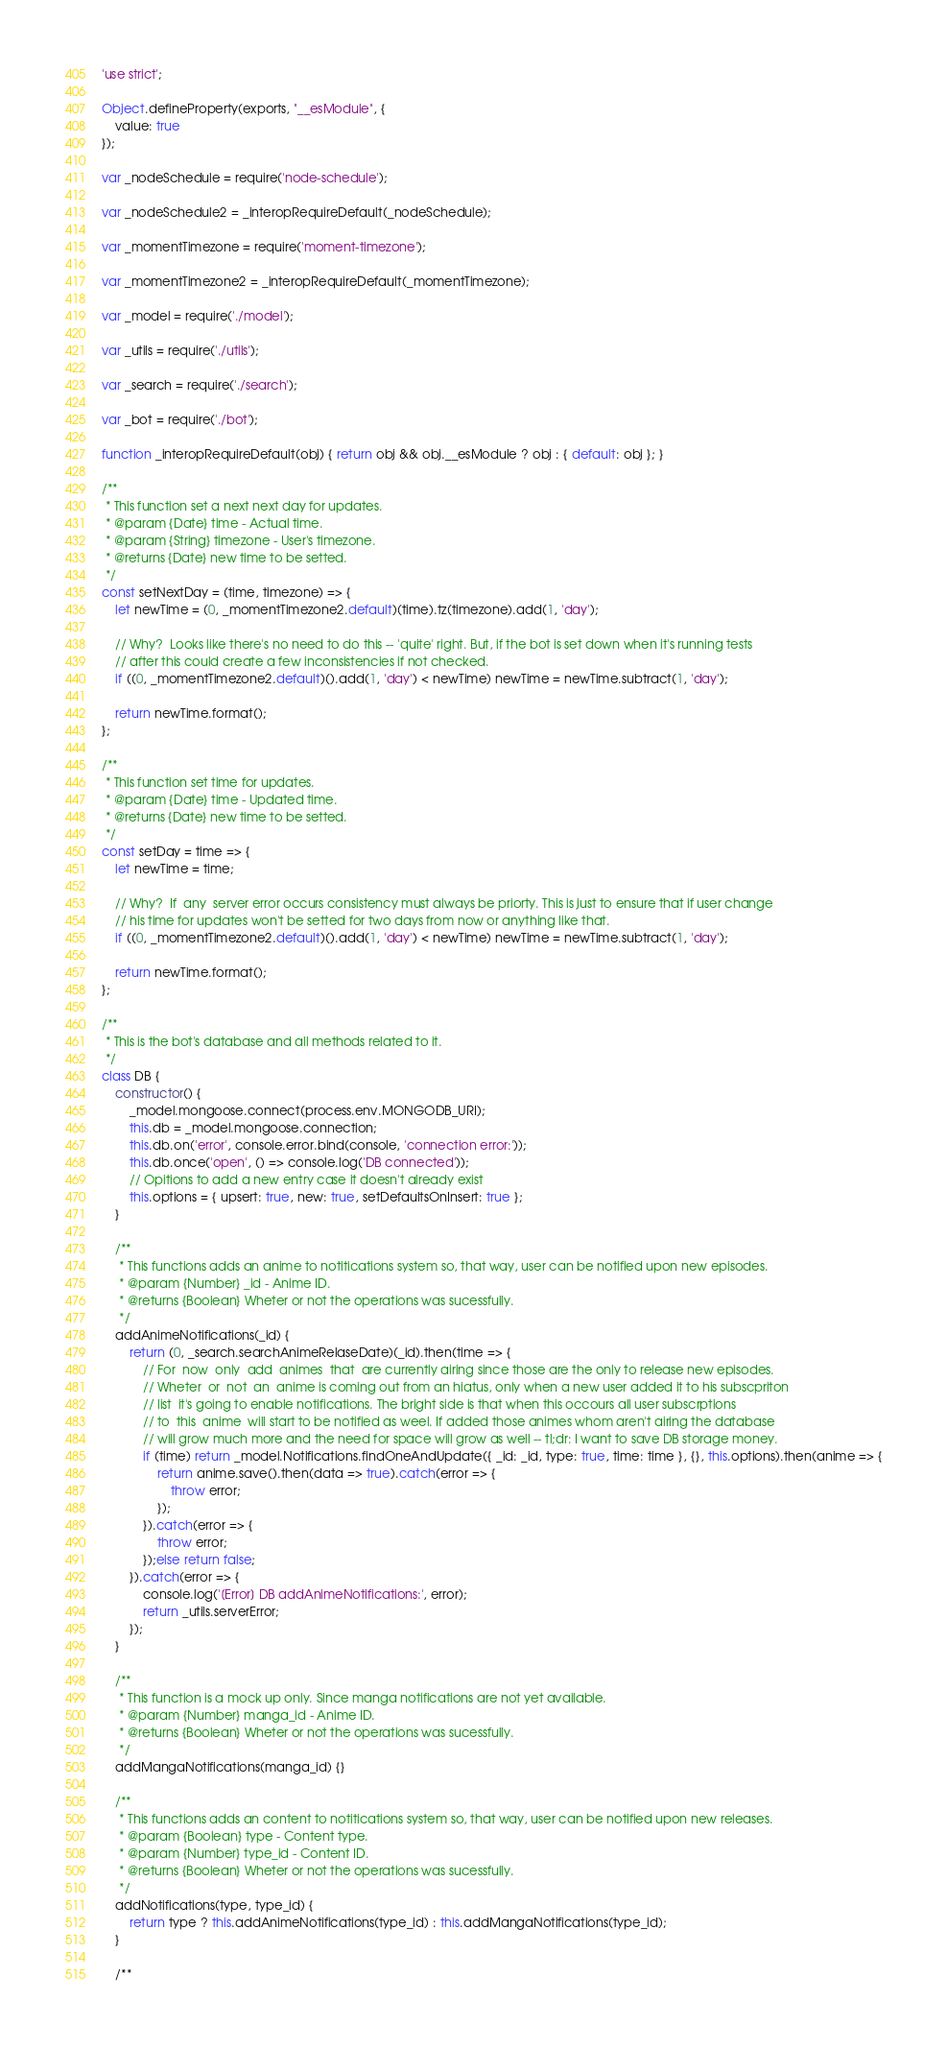Convert code to text. <code><loc_0><loc_0><loc_500><loc_500><_JavaScript_>'use strict';

Object.defineProperty(exports, "__esModule", {
    value: true
});

var _nodeSchedule = require('node-schedule');

var _nodeSchedule2 = _interopRequireDefault(_nodeSchedule);

var _momentTimezone = require('moment-timezone');

var _momentTimezone2 = _interopRequireDefault(_momentTimezone);

var _model = require('./model');

var _utils = require('./utils');

var _search = require('./search');

var _bot = require('./bot');

function _interopRequireDefault(obj) { return obj && obj.__esModule ? obj : { default: obj }; }

/**
 * This function set a next next day for updates.
 * @param {Date} time - Actual time.
 * @param {String} timezone - User's timezone.
 * @returns {Date} new time to be setted.
 */
const setNextDay = (time, timezone) => {
    let newTime = (0, _momentTimezone2.default)(time).tz(timezone).add(1, 'day');

    // Why?  Looks like there's no need to do this -- 'quite' right. But, if the bot is set down when it's running tests
    // after this could create a few inconsistencies if not checked.
    if ((0, _momentTimezone2.default)().add(1, 'day') < newTime) newTime = newTime.subtract(1, 'day');

    return newTime.format();
};

/**
 * This function set time for updates.
 * @param {Date} time - Updated time.
 * @returns {Date} new time to be setted.
 */
const setDay = time => {
    let newTime = time;

    // Why?  If  any  server error occurs consistency must always be priorty. This is just to ensure that if user change
    // his time for updates won't be setted for two days from now or anything like that.
    if ((0, _momentTimezone2.default)().add(1, 'day') < newTime) newTime = newTime.subtract(1, 'day');

    return newTime.format();
};

/**
 * This is the bot's database and all methods related to it.
 */
class DB {
    constructor() {
        _model.mongoose.connect(process.env.MONGODB_URI);
        this.db = _model.mongoose.connection;
        this.db.on('error', console.error.bind(console, 'connection error:'));
        this.db.once('open', () => console.log('DB connected'));
        // Opitions to add a new entry case it doesn't already exist
        this.options = { upsert: true, new: true, setDefaultsOnInsert: true };
    }

    /**
     * This functions adds an anime to notitications system so, that way, user can be notified upon new episodes.
     * @param {Number} _id - Anime ID.
     * @returns {Boolean} Wheter or not the operations was sucessfully.
     */
    addAnimeNotifications(_id) {
        return (0, _search.searchAnimeRelaseDate)(_id).then(time => {
            // For  now  only  add  animes  that  are currently airing since those are the only to release new episodes.
            // Wheter  or  not  an  anime is coming out from an hiatus, only when a new user added it to his subscpriton
            // list  it's going to enable notifications. The bright side is that when this occours all user subscrptions
            // to  this  anime  will start to be notified as weel. If added those animes whom aren't airing the database
            // will grow much more and the need for space will grow as well -- tl;dr: I want to save DB storage money.
            if (time) return _model.Notifications.findOneAndUpdate({ _id: _id, type: true, time: time }, {}, this.options).then(anime => {
                return anime.save().then(data => true).catch(error => {
                    throw error;
                });
            }).catch(error => {
                throw error;
            });else return false;
        }).catch(error => {
            console.log('[Error] DB addAnimeNotifications:', error);
            return _utils.serverError;
        });
    }

    /**
     * This function is a mock up only. Since manga notifications are not yet available.
     * @param {Number} manga_id - Anime ID.
     * @returns {Boolean} Wheter or not the operations was sucessfully.
     */
    addMangaNotifications(manga_id) {}

    /**
     * This functions adds an content to notitications system so, that way, user can be notified upon new releases.
     * @param {Boolean} type - Content type.
     * @param {Number} type_id - Content ID.
     * @returns {Boolean} Wheter or not the operations was sucessfully.
     */
    addNotifications(type, type_id) {
        return type ? this.addAnimeNotifications(type_id) : this.addMangaNotifications(type_id);
    }

    /**</code> 